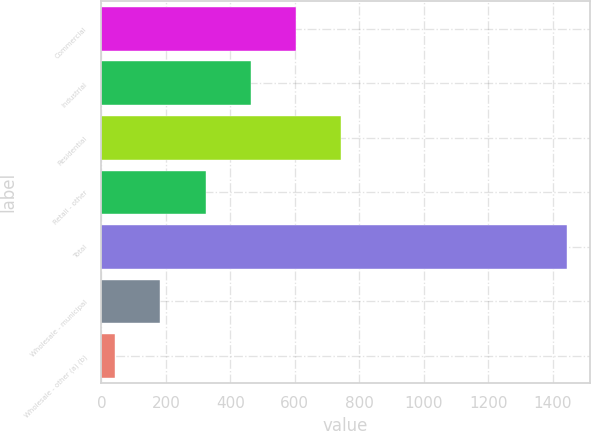Convert chart to OTSL. <chart><loc_0><loc_0><loc_500><loc_500><bar_chart><fcel>Commercial<fcel>Industrial<fcel>Residential<fcel>Retail - other<fcel>Total<fcel>Wholesale - municipal<fcel>Wholesale - other (a) (b)<nl><fcel>603.4<fcel>463.3<fcel>743.5<fcel>323.2<fcel>1444<fcel>183.1<fcel>43<nl></chart> 